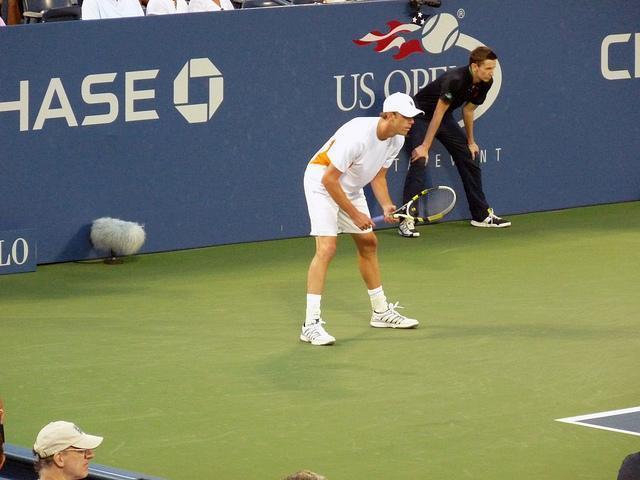How many people can be seen?
Give a very brief answer. 3. 